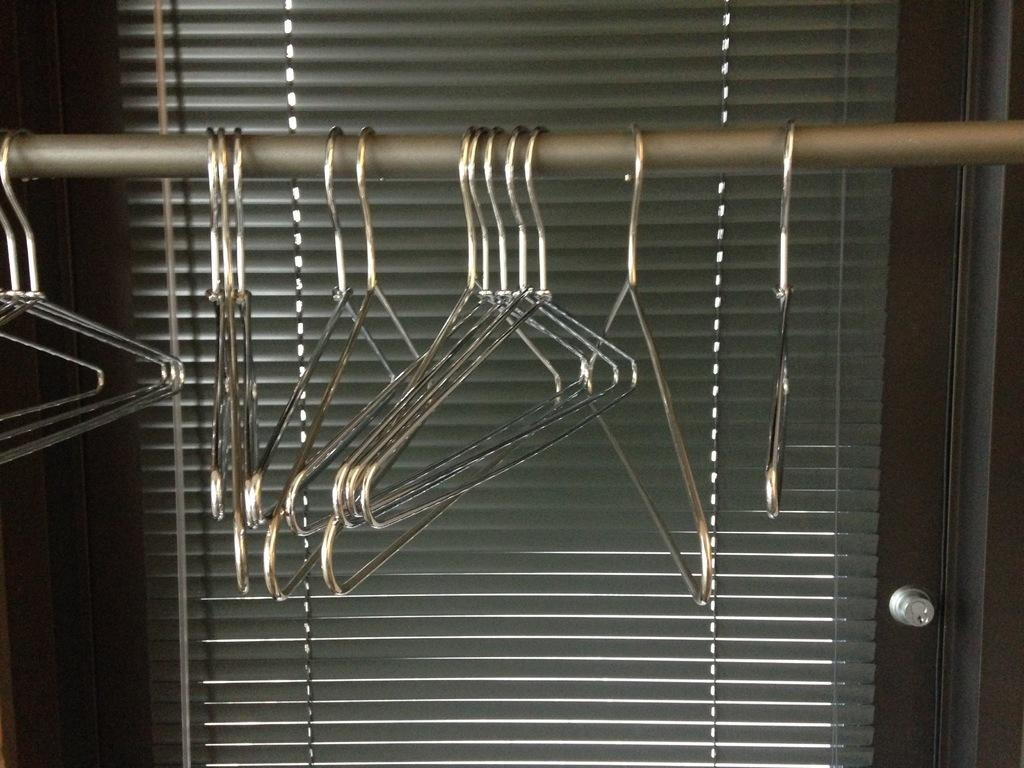What objects are hanging on the rod in the image? There are hangers on a rod in the image. What can be seen behind the hangers in the image? There is a door visible behind the hangers in the image. How many people are smiling while holding weights in the image? There are no people, smiling or otherwise, holding weights in the image. The image only features hangers on a rod and a door. 